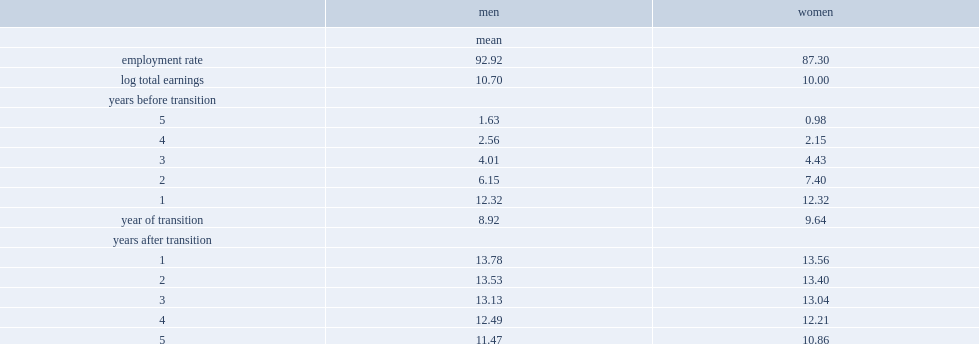What are the employment rates of male tfws? 92.92. What are the employment rates of female tfws? 87.3. Among tfws who have earnings, who earned more, men or women? Men. 